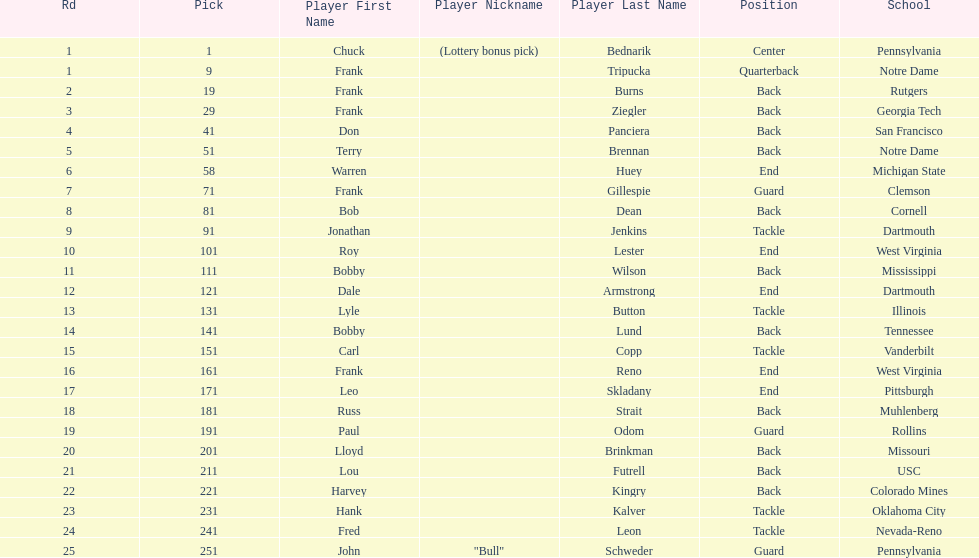Was chuck bednarik or frank tripucka the first draft pick? Chuck Bednarik. 